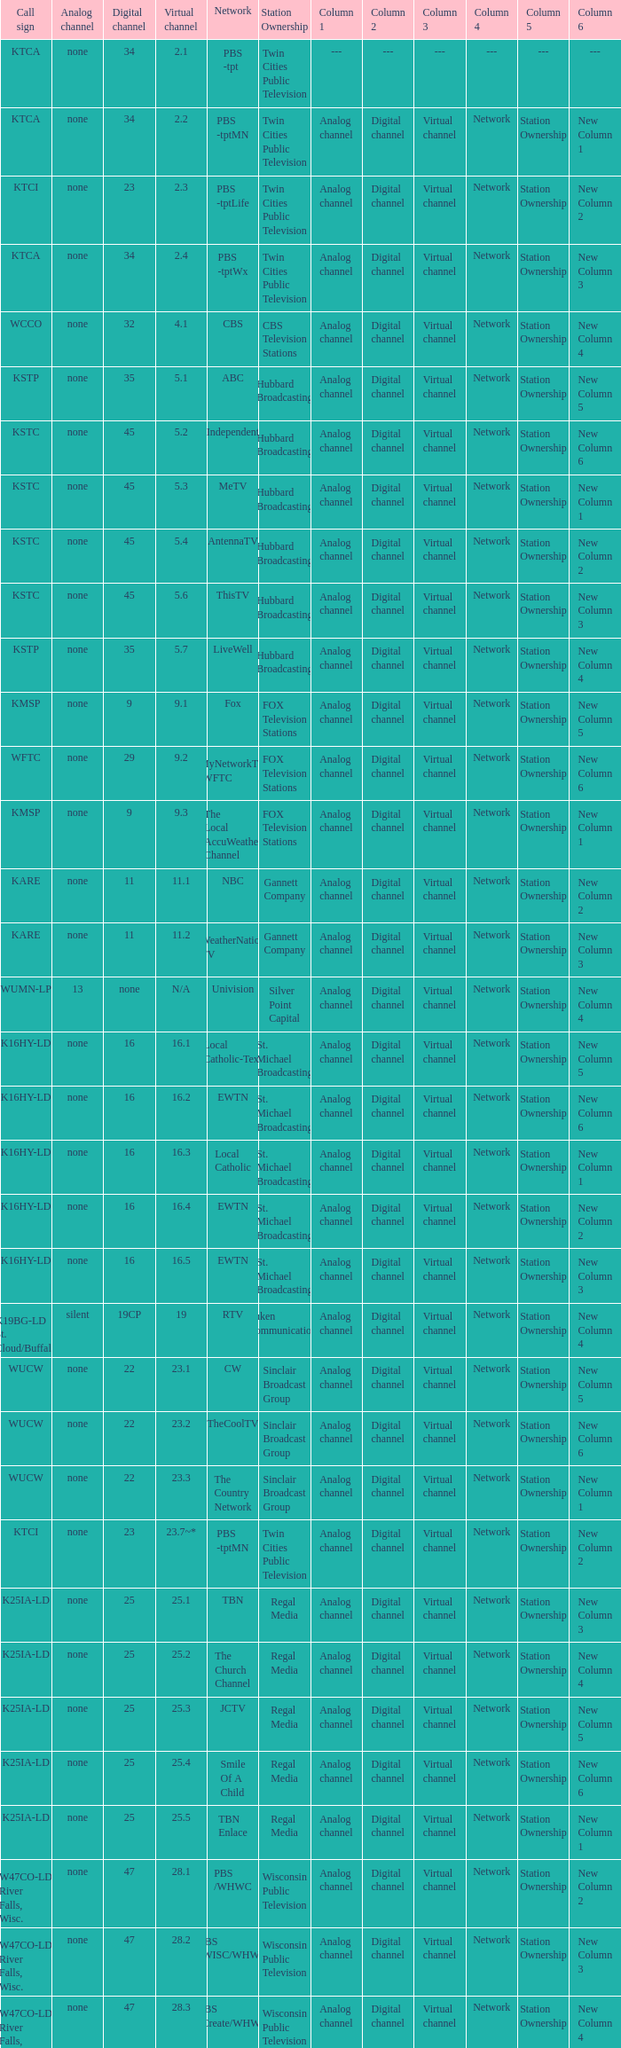Virtual channel of 16.5 has what call sign? K16HY-LD. 